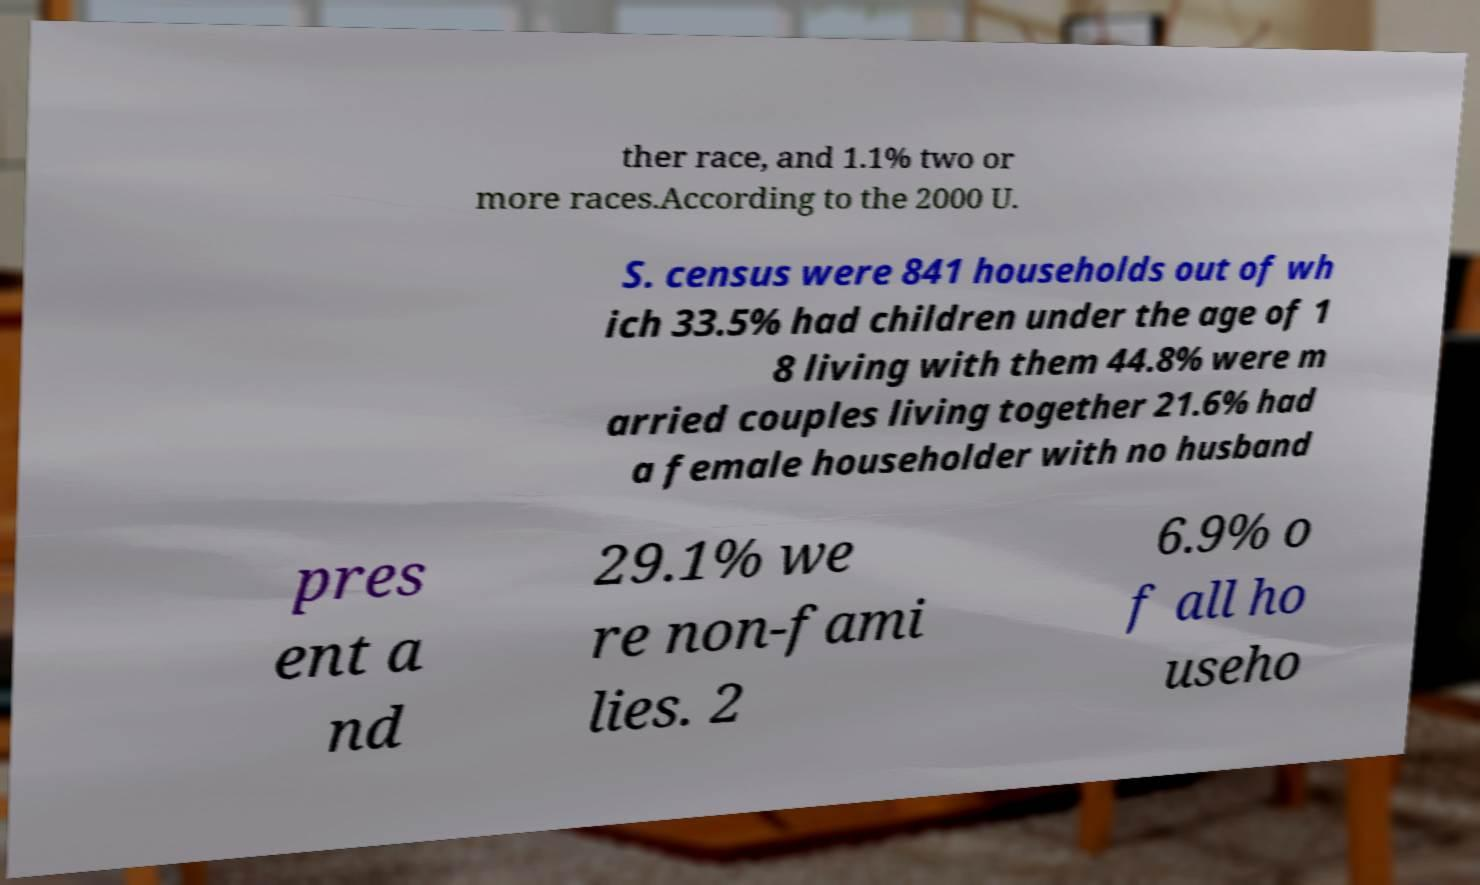Could you extract and type out the text from this image? ther race, and 1.1% two or more races.According to the 2000 U. S. census were 841 households out of wh ich 33.5% had children under the age of 1 8 living with them 44.8% were m arried couples living together 21.6% had a female householder with no husband pres ent a nd 29.1% we re non-fami lies. 2 6.9% o f all ho useho 